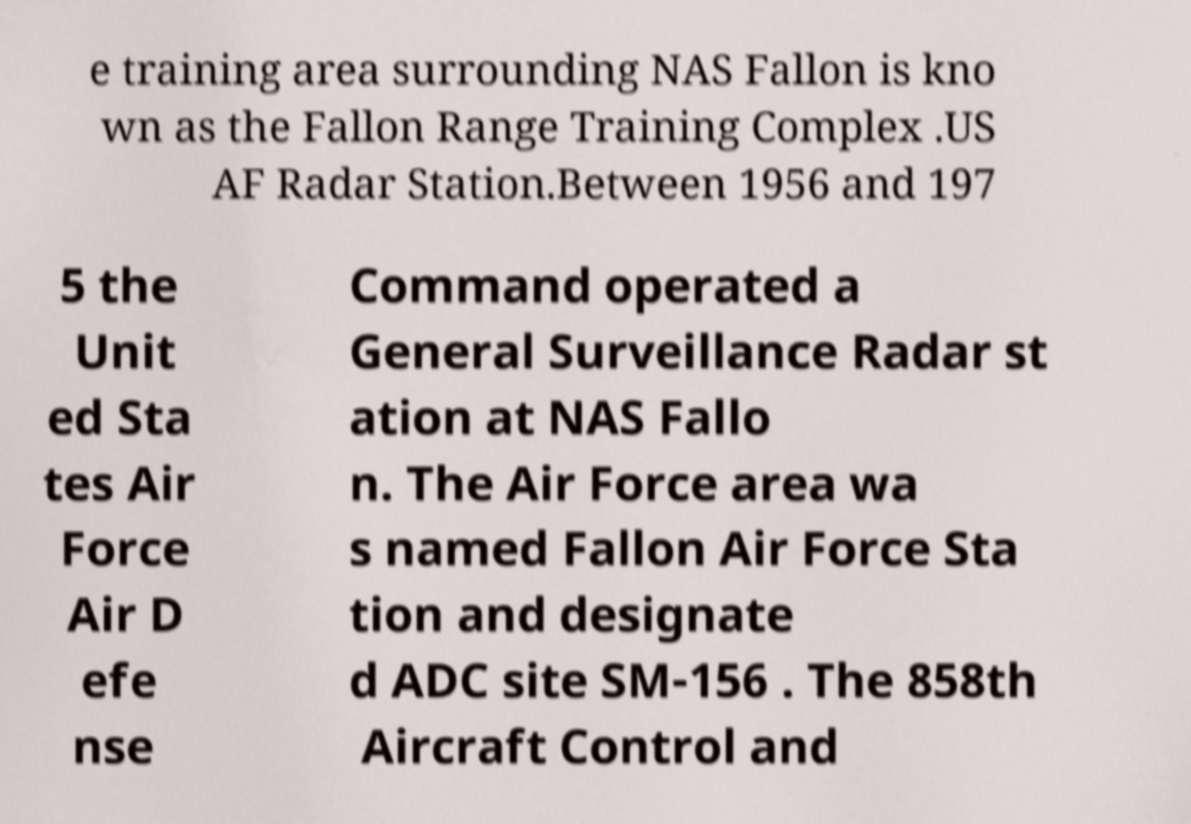For documentation purposes, I need the text within this image transcribed. Could you provide that? e training area surrounding NAS Fallon is kno wn as the Fallon Range Training Complex .US AF Radar Station.Between 1956 and 197 5 the Unit ed Sta tes Air Force Air D efe nse Command operated a General Surveillance Radar st ation at NAS Fallo n. The Air Force area wa s named Fallon Air Force Sta tion and designate d ADC site SM-156 . The 858th Aircraft Control and 